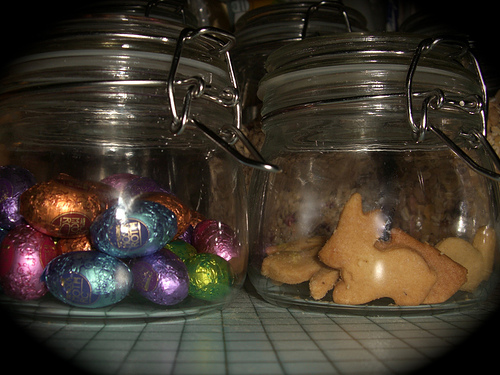<image>
Is there a chocolates to the left of the biscuit? Yes. From this viewpoint, the chocolates is positioned to the left side relative to the biscuit. Is there a egg candy in the jar? Yes. The egg candy is contained within or inside the jar, showing a containment relationship. 